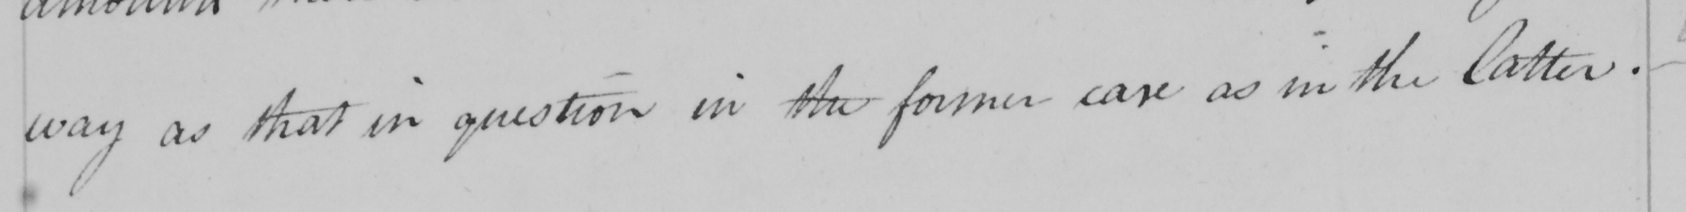Can you tell me what this handwritten text says? way as that in question in the former case as in the latter. 